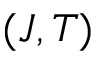<formula> <loc_0><loc_0><loc_500><loc_500>( J , T )</formula> 